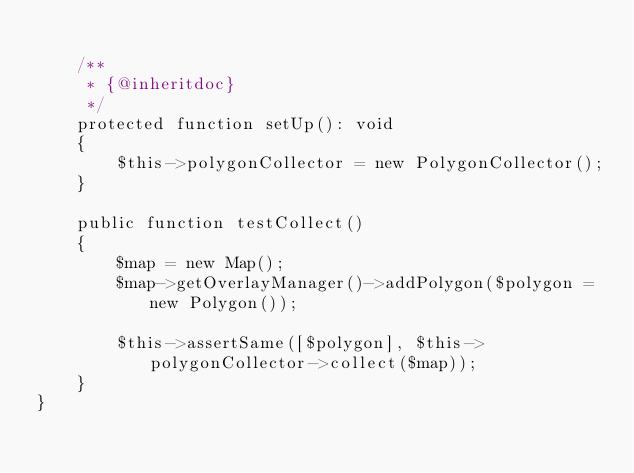<code> <loc_0><loc_0><loc_500><loc_500><_PHP_>
    /**
     * {@inheritdoc}
     */
    protected function setUp(): void
    {
        $this->polygonCollector = new PolygonCollector();
    }

    public function testCollect()
    {
        $map = new Map();
        $map->getOverlayManager()->addPolygon($polygon = new Polygon());

        $this->assertSame([$polygon], $this->polygonCollector->collect($map));
    }
}
</code> 